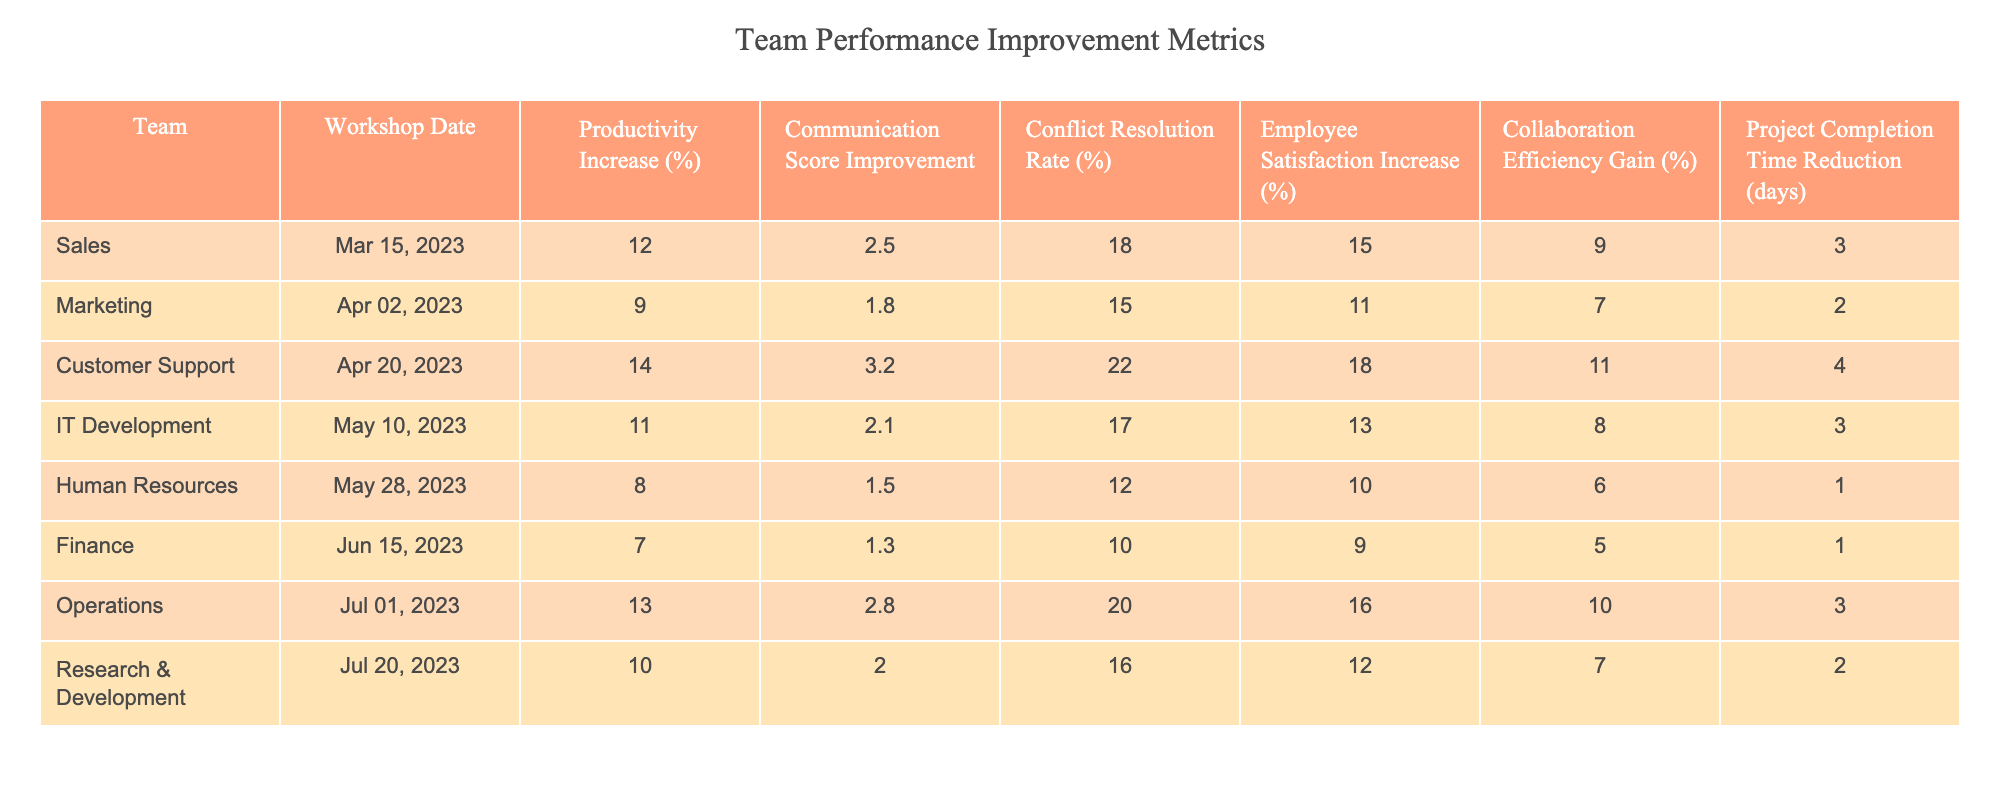What was the productivity increase for the Customer Support team? According to the table, the productivity increase for the Customer Support team is listed next to it. It shows a value of 14%.
Answer: 14% Which team experienced the highest conflict resolution rate? By examining the conflict resolution rates in the table, the Customer Support team has the highest value at 22%.
Answer: 22% What is the average employee satisfaction increase across all teams? To find the average, add the employee satisfaction increases for all teams (15 + 11 + 18 + 13 + 10 + 9 + 16 + 12 = 104) and then divide by the number of teams (8). The average is 104 / 8 = 13%.
Answer: 13% Did the Human Resources team have a higher productivity increase than the Finance team? By comparing the values for productivity increase, the Human Resources team had an increase of 8%, while the Finance team had 7%. Since 8% is greater than 7%, the statement is true.
Answer: Yes What is the difference in collaboration efficiency gain between the Sales and Marketing teams? From the table, the collaboration efficiency gain for the Sales team is 9%, and for the Marketing team, it is 7%. The difference is calculated by subtracting Marketing's value from Sales' value: 9% - 7% = 2%.
Answer: 2% Which team had the lowest project completion time reduction, and what was that reduction? Looking at the project completion time reductions, the Human Resources and Finance teams both had the lowest reduction at 1 day.
Answer: Human Resources/Finance, 1 day How does the productivity increase of the Operations team compare to that of the IT Development team? The Operations team had a productivity increase of 13%, while the IT Development team had an increase of 11%. The Operations team performed better with a 2% higher increase.
Answer: Operations is higher by 2% What is the total percentage increase in employee satisfaction for the Sales and IT Development teams combined? The employee satisfaction increases for both teams are 15% for Sales and 13% for IT Development. Adding them together gives 15% + 13% = 28%.
Answer: 28% Is it true that all teams experienced an increase in productivity? By checking the productivity increases listed for each team, all the values are positive, indicating indeed that every team had a productivity increase.
Answer: Yes Which team had the second highest communication score improvement? The Customer Support team has the highest communication score improvement at 3.2, followed by the Operations team at 2.8, thus making it the second highest.
Answer: Operations, 2.8 